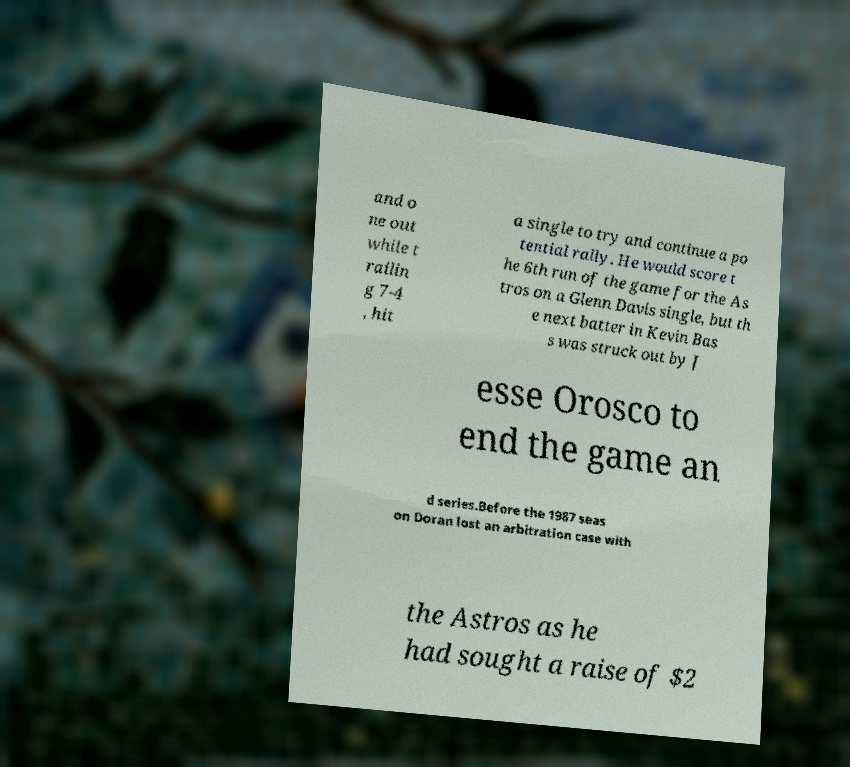What messages or text are displayed in this image? I need them in a readable, typed format. and o ne out while t railin g 7-4 , hit a single to try and continue a po tential rally. He would score t he 6th run of the game for the As tros on a Glenn Davis single, but th e next batter in Kevin Bas s was struck out by J esse Orosco to end the game an d series.Before the 1987 seas on Doran lost an arbitration case with the Astros as he had sought a raise of $2 